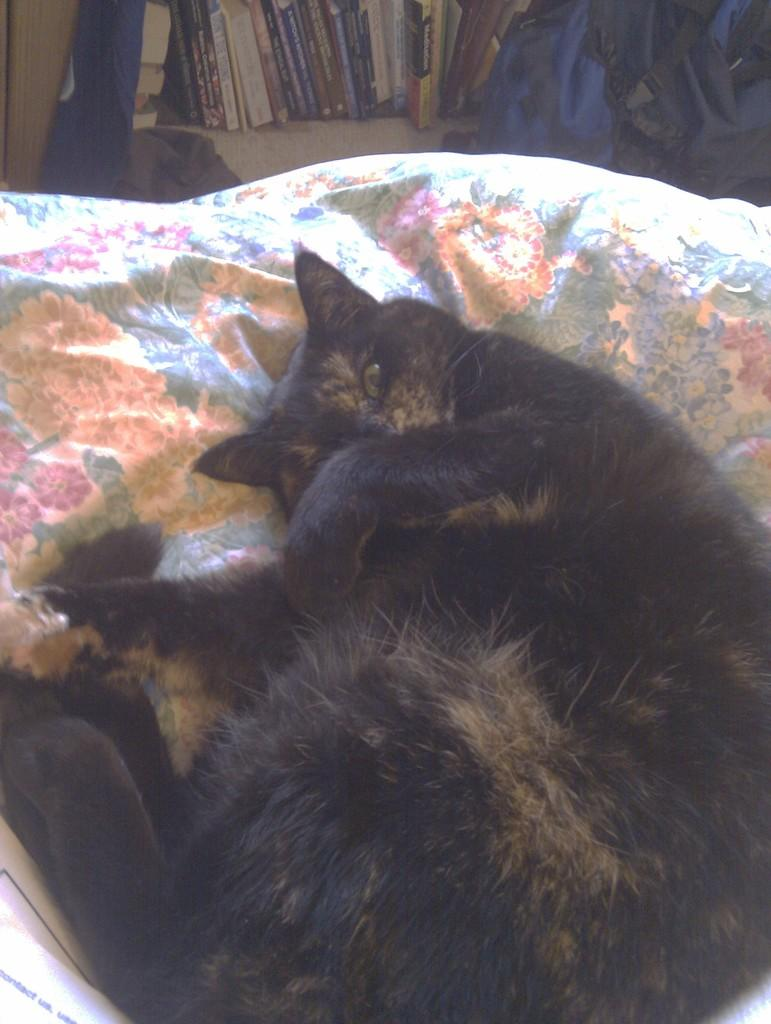What animal is in the foreground of the image? There is a black cat in the foreground of the image. What is the cat lying on? The cat is lying on a cloth. What can be seen in the background of the image? There is a bag and books on a shelf in the background. Is there any symbol or emblem visible in the image? Yes, there seems to be a flag in the top left corner of the image. What type of music is the cat playing in the image? There is no indication in the image that the cat is playing music, as cats do not have the ability to play musical instruments. 